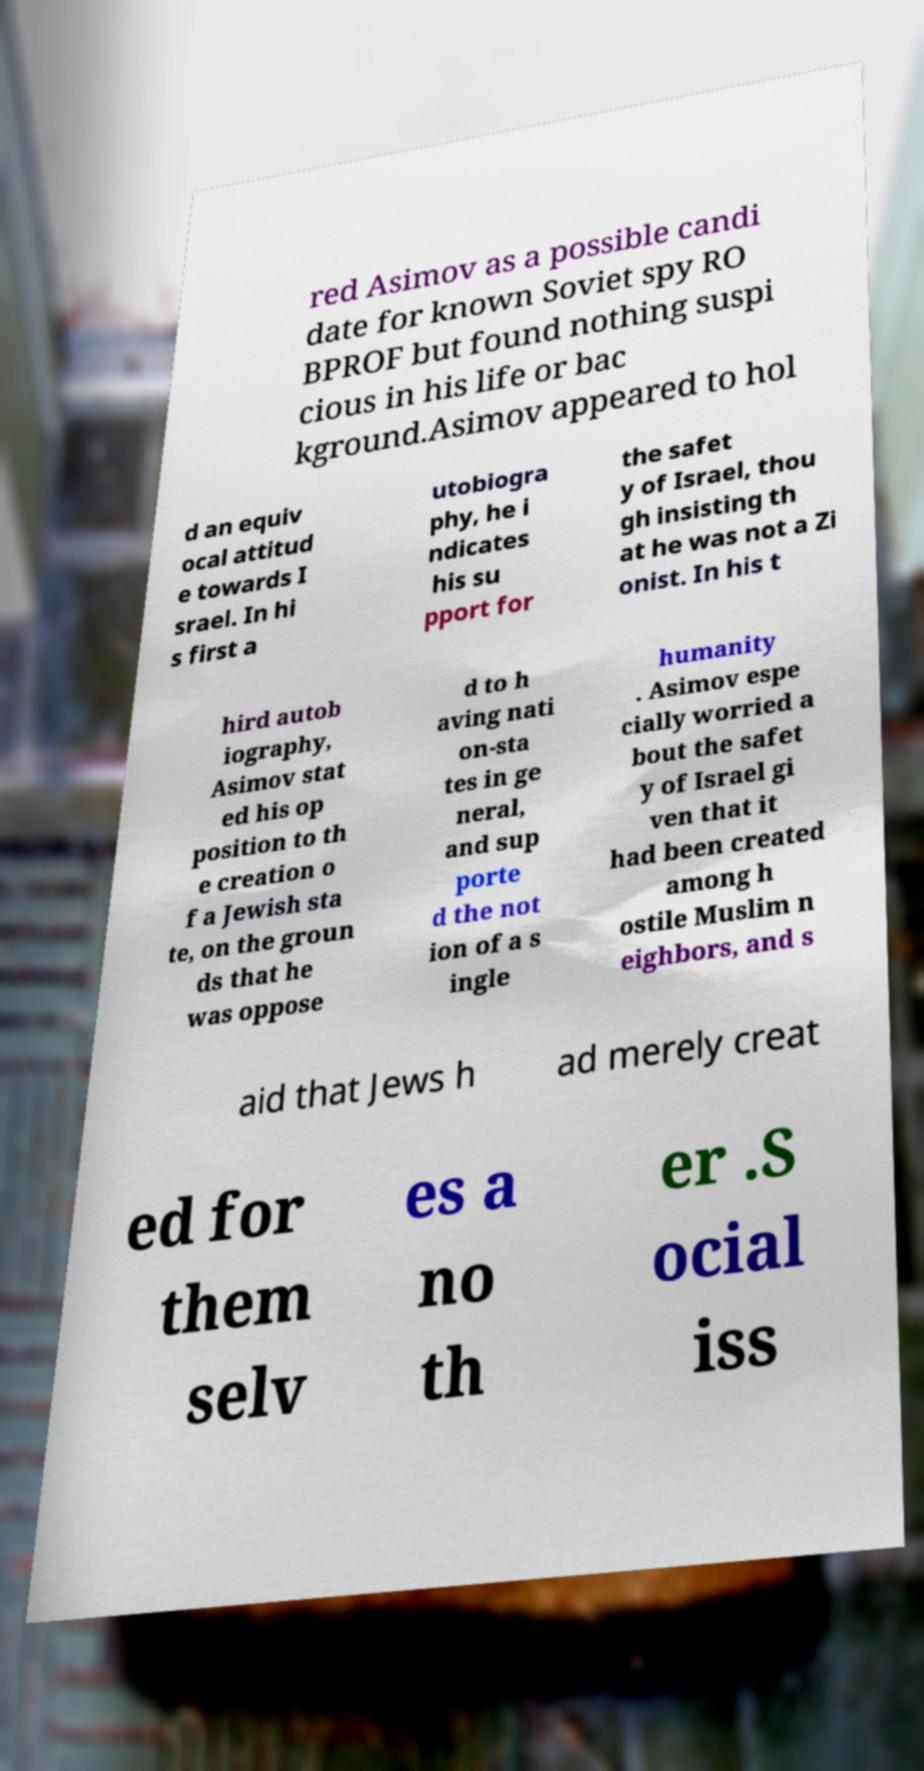Could you assist in decoding the text presented in this image and type it out clearly? red Asimov as a possible candi date for known Soviet spy RO BPROF but found nothing suspi cious in his life or bac kground.Asimov appeared to hol d an equiv ocal attitud e towards I srael. In hi s first a utobiogra phy, he i ndicates his su pport for the safet y of Israel, thou gh insisting th at he was not a Zi onist. In his t hird autob iography, Asimov stat ed his op position to th e creation o f a Jewish sta te, on the groun ds that he was oppose d to h aving nati on-sta tes in ge neral, and sup porte d the not ion of a s ingle humanity . Asimov espe cially worried a bout the safet y of Israel gi ven that it had been created among h ostile Muslim n eighbors, and s aid that Jews h ad merely creat ed for them selv es a no th er .S ocial iss 